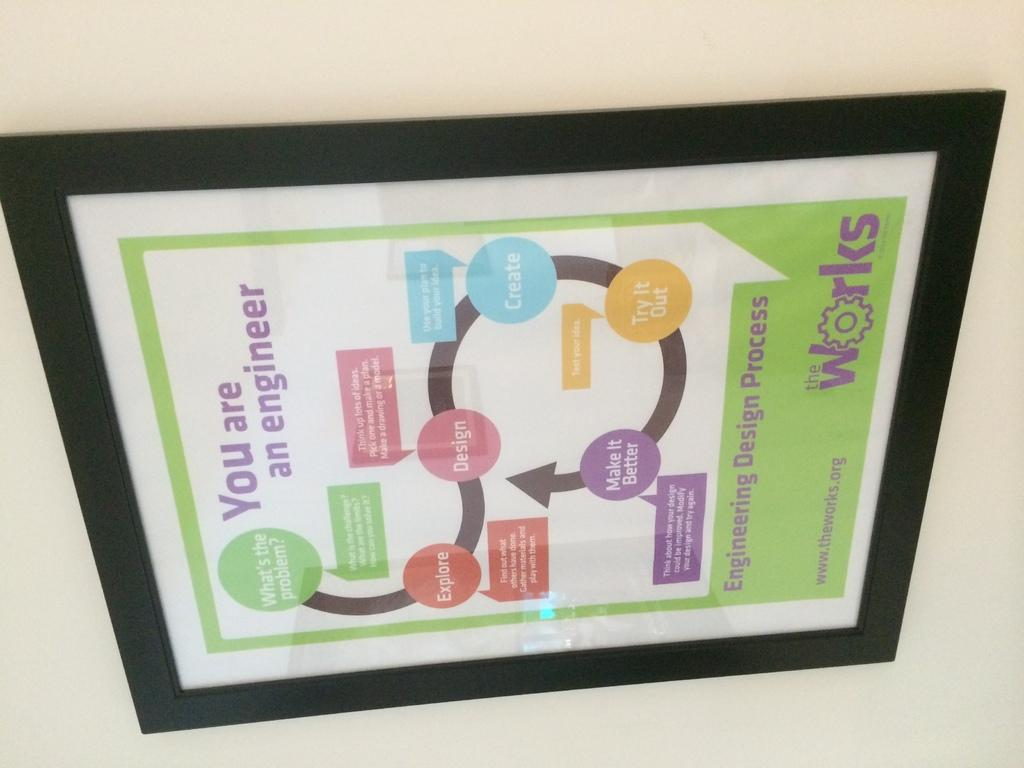<image>
Write a terse but informative summary of the picture. A poster from the Works that reads you are an engineer. 